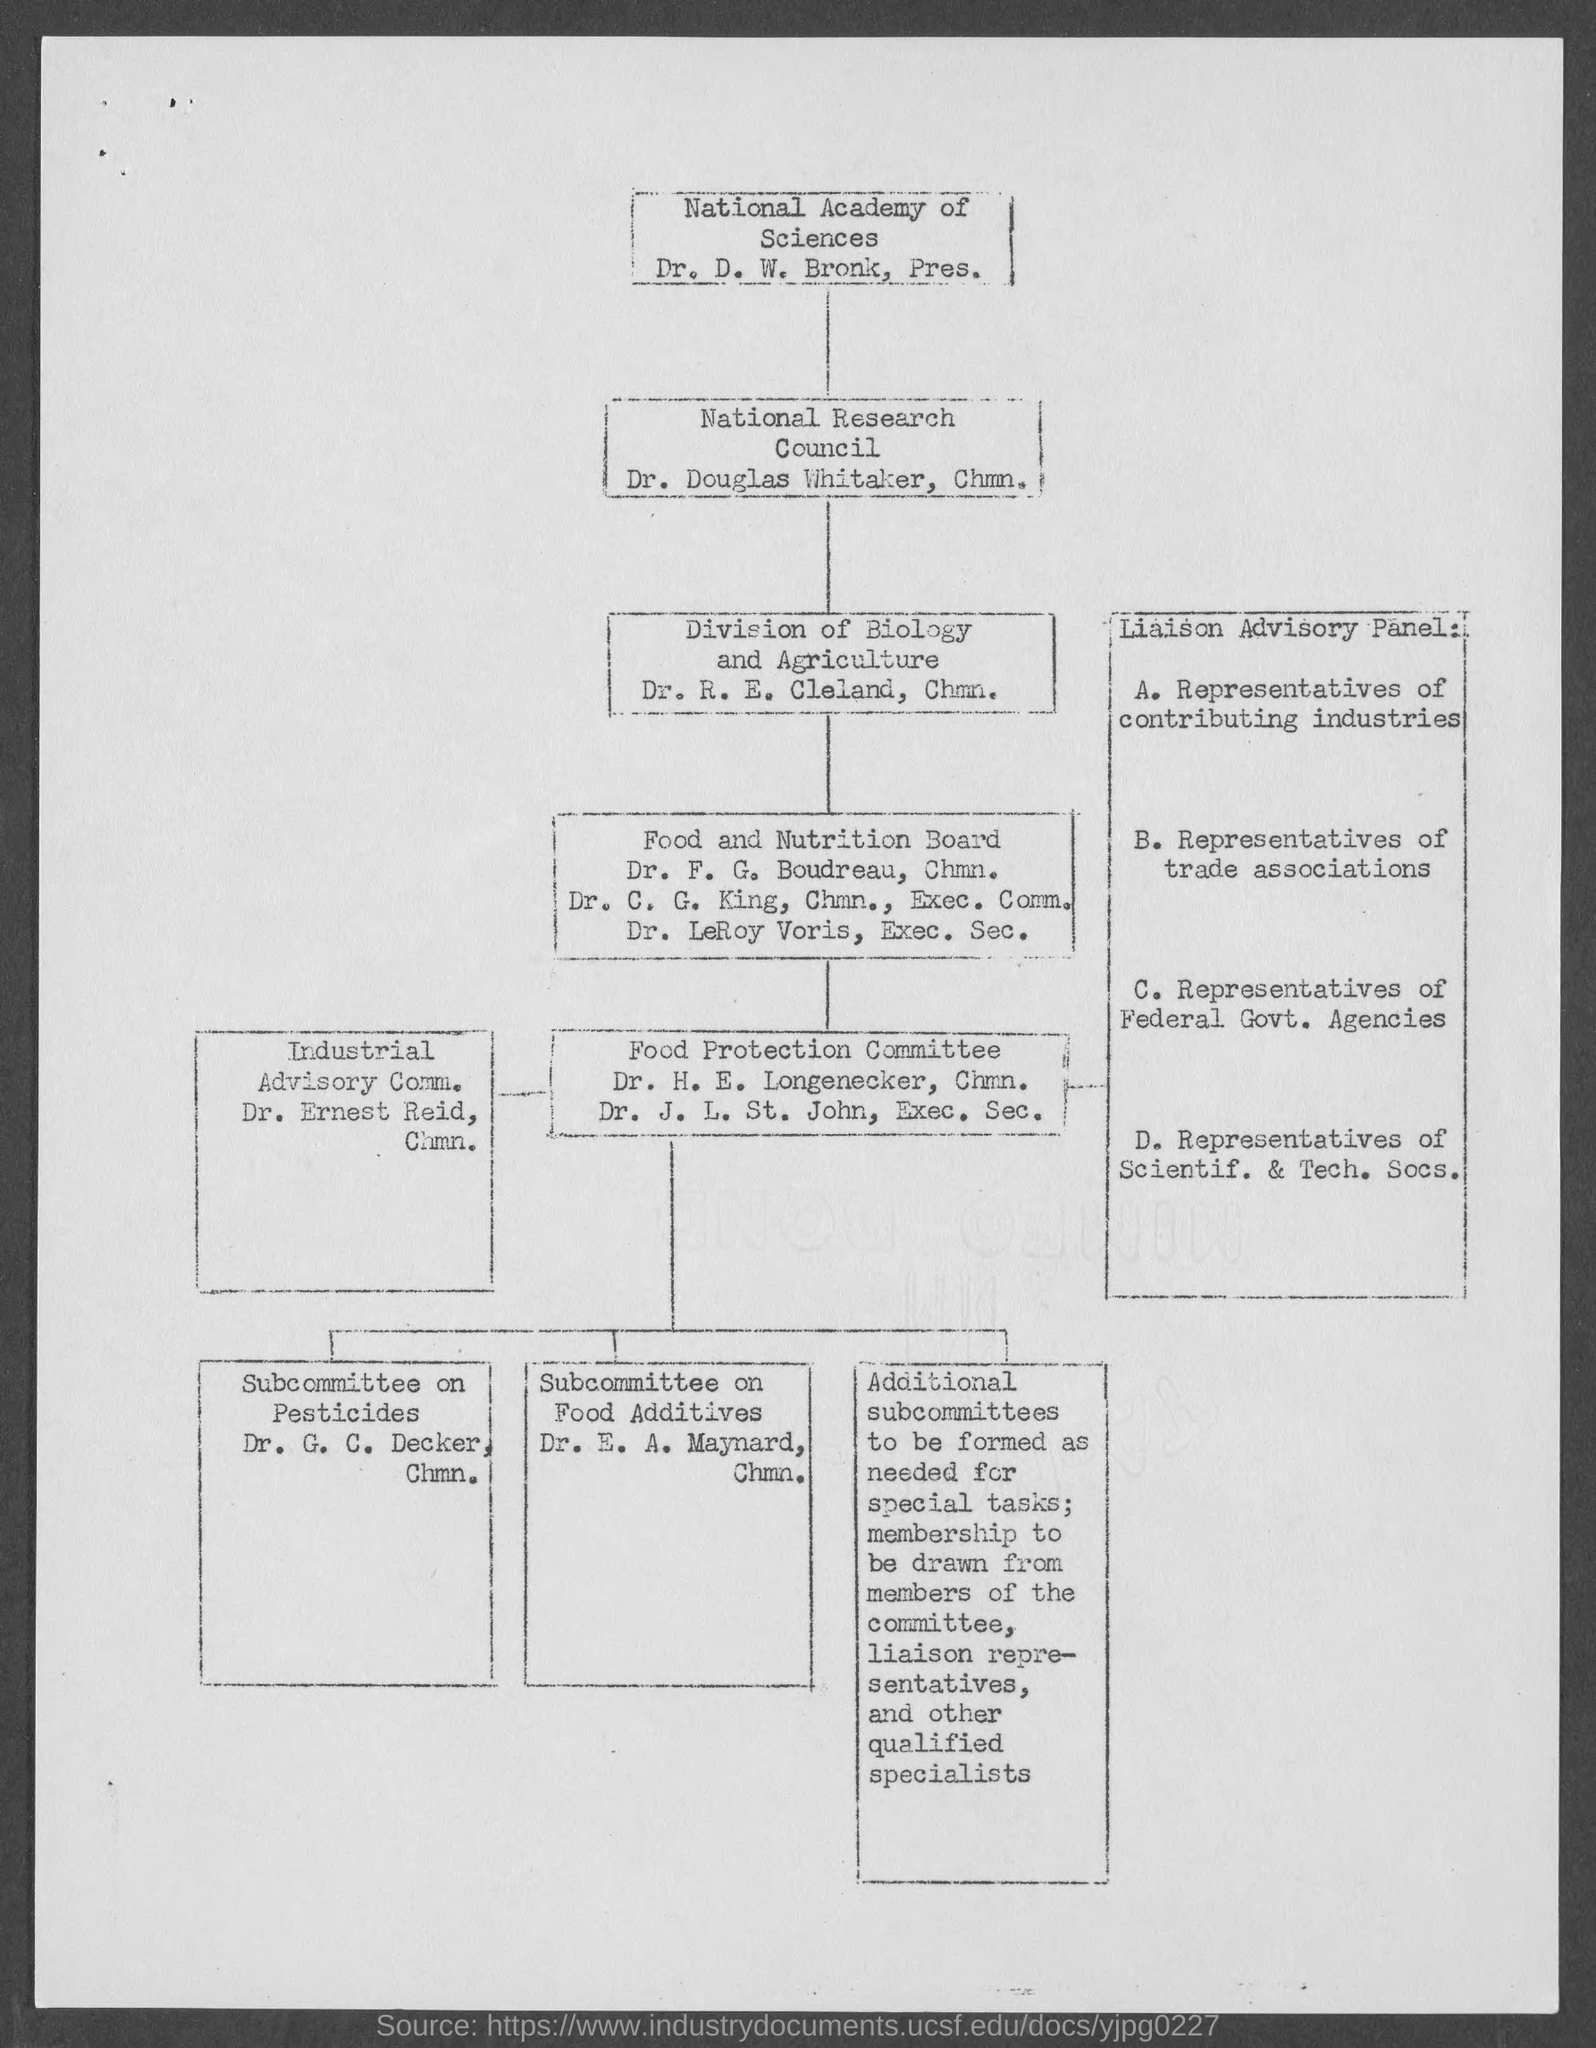Give some essential details in this illustration. Dr. G. C. Decker holds the position of Chairman. Dr. H.E. Longenecker holds the position of chairman. Dr. F. G. Boudreau holds the position of chairman. Dr. Douglas Whitaker holds the position of Chairman. Dr. R.E. Cleland holds the position of Chairman. 